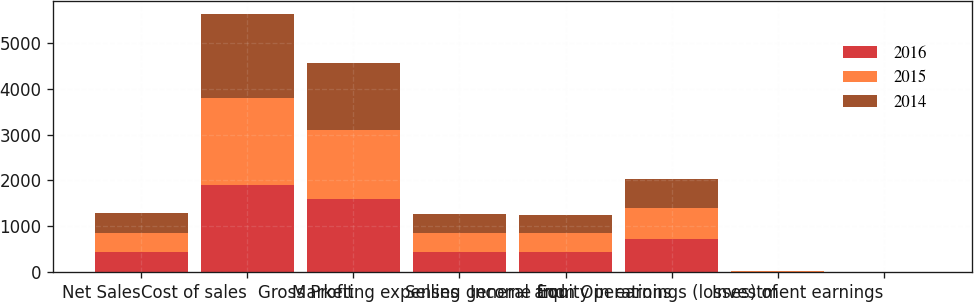Convert chart. <chart><loc_0><loc_0><loc_500><loc_500><stacked_bar_chart><ecel><fcel>Net Sales<fcel>Cost of sales<fcel>Gross Profit<fcel>Marketing expenses<fcel>Selling general and<fcel>Income from Operations<fcel>Equity in earnings (losses) of<fcel>Investment earnings<nl><fcel>2016<fcel>427.2<fcel>1902.5<fcel>1590.6<fcel>427.2<fcel>439.2<fcel>724.2<fcel>9.2<fcel>1.7<nl><fcel>2015<fcel>427.2<fcel>1883<fcel>1511.8<fcel>417.5<fcel>420.1<fcel>674.2<fcel>5.8<fcel>1.5<nl><fcel>2014<fcel>427.2<fcel>1844.7<fcel>1452.9<fcel>416.9<fcel>394.8<fcel>641.2<fcel>11.6<fcel>2.3<nl></chart> 